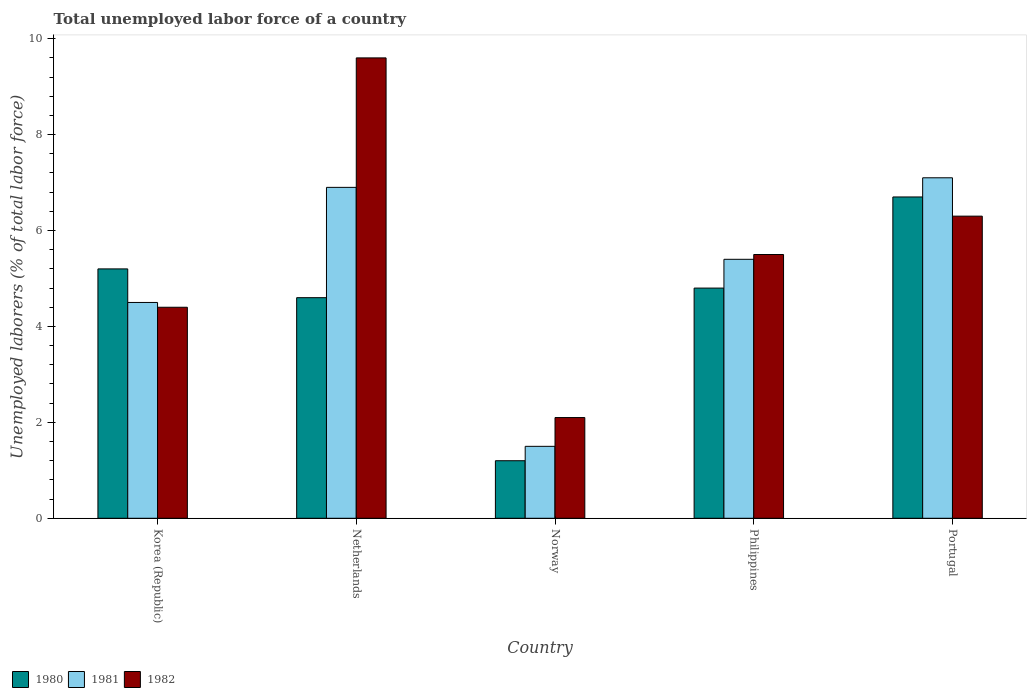How many different coloured bars are there?
Make the answer very short. 3. How many groups of bars are there?
Your answer should be very brief. 5. Are the number of bars per tick equal to the number of legend labels?
Your answer should be compact. Yes. How many bars are there on the 5th tick from the right?
Your answer should be very brief. 3. What is the label of the 3rd group of bars from the left?
Offer a terse response. Norway. What is the total unemployed labor force in 1982 in Netherlands?
Give a very brief answer. 9.6. Across all countries, what is the maximum total unemployed labor force in 1982?
Give a very brief answer. 9.6. Across all countries, what is the minimum total unemployed labor force in 1981?
Ensure brevity in your answer.  1.5. In which country was the total unemployed labor force in 1981 maximum?
Provide a succinct answer. Portugal. In which country was the total unemployed labor force in 1980 minimum?
Make the answer very short. Norway. What is the total total unemployed labor force in 1981 in the graph?
Keep it short and to the point. 25.4. What is the difference between the total unemployed labor force in 1980 in Norway and that in Portugal?
Your response must be concise. -5.5. What is the difference between the total unemployed labor force in 1980 in Norway and the total unemployed labor force in 1982 in Philippines?
Make the answer very short. -4.3. What is the average total unemployed labor force in 1980 per country?
Offer a terse response. 4.5. What is the difference between the total unemployed labor force of/in 1981 and total unemployed labor force of/in 1980 in Norway?
Offer a very short reply. 0.3. What is the ratio of the total unemployed labor force in 1980 in Norway to that in Philippines?
Your response must be concise. 0.25. Is the total unemployed labor force in 1982 in Netherlands less than that in Philippines?
Offer a terse response. No. What is the difference between the highest and the second highest total unemployed labor force in 1980?
Your response must be concise. -0.4. What is the difference between the highest and the lowest total unemployed labor force in 1980?
Keep it short and to the point. 5.5. Is the sum of the total unemployed labor force in 1982 in Netherlands and Philippines greater than the maximum total unemployed labor force in 1981 across all countries?
Provide a succinct answer. Yes. How many bars are there?
Offer a terse response. 15. Are all the bars in the graph horizontal?
Give a very brief answer. No. Are the values on the major ticks of Y-axis written in scientific E-notation?
Keep it short and to the point. No. Does the graph contain any zero values?
Give a very brief answer. No. Does the graph contain grids?
Your response must be concise. No. Where does the legend appear in the graph?
Your response must be concise. Bottom left. What is the title of the graph?
Provide a short and direct response. Total unemployed labor force of a country. What is the label or title of the Y-axis?
Your answer should be compact. Unemployed laborers (% of total labor force). What is the Unemployed laborers (% of total labor force) of 1980 in Korea (Republic)?
Your response must be concise. 5.2. What is the Unemployed laborers (% of total labor force) of 1981 in Korea (Republic)?
Provide a short and direct response. 4.5. What is the Unemployed laborers (% of total labor force) in 1982 in Korea (Republic)?
Offer a terse response. 4.4. What is the Unemployed laborers (% of total labor force) in 1980 in Netherlands?
Offer a very short reply. 4.6. What is the Unemployed laborers (% of total labor force) of 1981 in Netherlands?
Make the answer very short. 6.9. What is the Unemployed laborers (% of total labor force) in 1982 in Netherlands?
Offer a terse response. 9.6. What is the Unemployed laborers (% of total labor force) of 1980 in Norway?
Ensure brevity in your answer.  1.2. What is the Unemployed laborers (% of total labor force) in 1982 in Norway?
Make the answer very short. 2.1. What is the Unemployed laborers (% of total labor force) of 1980 in Philippines?
Offer a terse response. 4.8. What is the Unemployed laborers (% of total labor force) in 1981 in Philippines?
Give a very brief answer. 5.4. What is the Unemployed laborers (% of total labor force) in 1982 in Philippines?
Your response must be concise. 5.5. What is the Unemployed laborers (% of total labor force) in 1980 in Portugal?
Provide a succinct answer. 6.7. What is the Unemployed laborers (% of total labor force) of 1981 in Portugal?
Offer a terse response. 7.1. What is the Unemployed laborers (% of total labor force) of 1982 in Portugal?
Your response must be concise. 6.3. Across all countries, what is the maximum Unemployed laborers (% of total labor force) of 1980?
Your response must be concise. 6.7. Across all countries, what is the maximum Unemployed laborers (% of total labor force) of 1981?
Your answer should be compact. 7.1. Across all countries, what is the maximum Unemployed laborers (% of total labor force) in 1982?
Keep it short and to the point. 9.6. Across all countries, what is the minimum Unemployed laborers (% of total labor force) of 1980?
Provide a short and direct response. 1.2. Across all countries, what is the minimum Unemployed laborers (% of total labor force) of 1982?
Provide a short and direct response. 2.1. What is the total Unemployed laborers (% of total labor force) of 1980 in the graph?
Keep it short and to the point. 22.5. What is the total Unemployed laborers (% of total labor force) of 1981 in the graph?
Offer a terse response. 25.4. What is the total Unemployed laborers (% of total labor force) of 1982 in the graph?
Ensure brevity in your answer.  27.9. What is the difference between the Unemployed laborers (% of total labor force) in 1982 in Korea (Republic) and that in Netherlands?
Provide a succinct answer. -5.2. What is the difference between the Unemployed laborers (% of total labor force) in 1980 in Korea (Republic) and that in Norway?
Offer a very short reply. 4. What is the difference between the Unemployed laborers (% of total labor force) in 1981 in Korea (Republic) and that in Norway?
Your answer should be very brief. 3. What is the difference between the Unemployed laborers (% of total labor force) of 1982 in Korea (Republic) and that in Norway?
Give a very brief answer. 2.3. What is the difference between the Unemployed laborers (% of total labor force) of 1981 in Korea (Republic) and that in Portugal?
Your answer should be very brief. -2.6. What is the difference between the Unemployed laborers (% of total labor force) of 1982 in Korea (Republic) and that in Portugal?
Offer a very short reply. -1.9. What is the difference between the Unemployed laborers (% of total labor force) of 1980 in Netherlands and that in Norway?
Ensure brevity in your answer.  3.4. What is the difference between the Unemployed laborers (% of total labor force) in 1981 in Netherlands and that in Norway?
Provide a succinct answer. 5.4. What is the difference between the Unemployed laborers (% of total labor force) in 1982 in Netherlands and that in Norway?
Offer a terse response. 7.5. What is the difference between the Unemployed laborers (% of total labor force) in 1980 in Netherlands and that in Philippines?
Provide a short and direct response. -0.2. What is the difference between the Unemployed laborers (% of total labor force) of 1980 in Netherlands and that in Portugal?
Offer a terse response. -2.1. What is the difference between the Unemployed laborers (% of total labor force) in 1982 in Netherlands and that in Portugal?
Provide a short and direct response. 3.3. What is the difference between the Unemployed laborers (% of total labor force) of 1980 in Norway and that in Philippines?
Provide a short and direct response. -3.6. What is the difference between the Unemployed laborers (% of total labor force) of 1981 in Norway and that in Philippines?
Make the answer very short. -3.9. What is the difference between the Unemployed laborers (% of total labor force) in 1982 in Norway and that in Philippines?
Your response must be concise. -3.4. What is the difference between the Unemployed laborers (% of total labor force) of 1982 in Norway and that in Portugal?
Your answer should be compact. -4.2. What is the difference between the Unemployed laborers (% of total labor force) in 1980 in Philippines and that in Portugal?
Your answer should be compact. -1.9. What is the difference between the Unemployed laborers (% of total labor force) in 1980 in Korea (Republic) and the Unemployed laborers (% of total labor force) in 1981 in Netherlands?
Your answer should be compact. -1.7. What is the difference between the Unemployed laborers (% of total labor force) of 1980 in Korea (Republic) and the Unemployed laborers (% of total labor force) of 1982 in Norway?
Provide a short and direct response. 3.1. What is the difference between the Unemployed laborers (% of total labor force) in 1980 in Korea (Republic) and the Unemployed laborers (% of total labor force) in 1982 in Philippines?
Your answer should be compact. -0.3. What is the difference between the Unemployed laborers (% of total labor force) of 1981 in Korea (Republic) and the Unemployed laborers (% of total labor force) of 1982 in Philippines?
Your answer should be very brief. -1. What is the difference between the Unemployed laborers (% of total labor force) of 1980 in Korea (Republic) and the Unemployed laborers (% of total labor force) of 1982 in Portugal?
Provide a succinct answer. -1.1. What is the difference between the Unemployed laborers (% of total labor force) of 1981 in Korea (Republic) and the Unemployed laborers (% of total labor force) of 1982 in Portugal?
Your answer should be compact. -1.8. What is the difference between the Unemployed laborers (% of total labor force) of 1980 in Netherlands and the Unemployed laborers (% of total labor force) of 1981 in Norway?
Give a very brief answer. 3.1. What is the difference between the Unemployed laborers (% of total labor force) of 1980 in Netherlands and the Unemployed laborers (% of total labor force) of 1982 in Philippines?
Offer a very short reply. -0.9. What is the difference between the Unemployed laborers (% of total labor force) of 1981 in Netherlands and the Unemployed laborers (% of total labor force) of 1982 in Philippines?
Make the answer very short. 1.4. What is the difference between the Unemployed laborers (% of total labor force) of 1980 in Netherlands and the Unemployed laborers (% of total labor force) of 1981 in Portugal?
Your answer should be very brief. -2.5. What is the difference between the Unemployed laborers (% of total labor force) in 1980 in Netherlands and the Unemployed laborers (% of total labor force) in 1982 in Portugal?
Provide a short and direct response. -1.7. What is the difference between the Unemployed laborers (% of total labor force) in 1980 in Norway and the Unemployed laborers (% of total labor force) in 1982 in Philippines?
Give a very brief answer. -4.3. What is the difference between the Unemployed laborers (% of total labor force) of 1980 in Norway and the Unemployed laborers (% of total labor force) of 1981 in Portugal?
Give a very brief answer. -5.9. What is the difference between the Unemployed laborers (% of total labor force) in 1980 in Norway and the Unemployed laborers (% of total labor force) in 1982 in Portugal?
Provide a succinct answer. -5.1. What is the difference between the Unemployed laborers (% of total labor force) in 1980 in Philippines and the Unemployed laborers (% of total labor force) in 1982 in Portugal?
Your answer should be compact. -1.5. What is the difference between the Unemployed laborers (% of total labor force) in 1981 in Philippines and the Unemployed laborers (% of total labor force) in 1982 in Portugal?
Give a very brief answer. -0.9. What is the average Unemployed laborers (% of total labor force) in 1980 per country?
Offer a very short reply. 4.5. What is the average Unemployed laborers (% of total labor force) of 1981 per country?
Ensure brevity in your answer.  5.08. What is the average Unemployed laborers (% of total labor force) of 1982 per country?
Provide a short and direct response. 5.58. What is the difference between the Unemployed laborers (% of total labor force) in 1980 and Unemployed laborers (% of total labor force) in 1981 in Korea (Republic)?
Make the answer very short. 0.7. What is the difference between the Unemployed laborers (% of total labor force) of 1980 and Unemployed laborers (% of total labor force) of 1982 in Netherlands?
Keep it short and to the point. -5. What is the difference between the Unemployed laborers (% of total labor force) of 1980 and Unemployed laborers (% of total labor force) of 1982 in Norway?
Provide a short and direct response. -0.9. What is the difference between the Unemployed laborers (% of total labor force) in 1981 and Unemployed laborers (% of total labor force) in 1982 in Norway?
Provide a short and direct response. -0.6. What is the difference between the Unemployed laborers (% of total labor force) in 1980 and Unemployed laborers (% of total labor force) in 1982 in Philippines?
Give a very brief answer. -0.7. What is the difference between the Unemployed laborers (% of total labor force) of 1981 and Unemployed laborers (% of total labor force) of 1982 in Philippines?
Your response must be concise. -0.1. What is the difference between the Unemployed laborers (% of total labor force) in 1981 and Unemployed laborers (% of total labor force) in 1982 in Portugal?
Your response must be concise. 0.8. What is the ratio of the Unemployed laborers (% of total labor force) of 1980 in Korea (Republic) to that in Netherlands?
Your answer should be very brief. 1.13. What is the ratio of the Unemployed laborers (% of total labor force) in 1981 in Korea (Republic) to that in Netherlands?
Your answer should be very brief. 0.65. What is the ratio of the Unemployed laborers (% of total labor force) of 1982 in Korea (Republic) to that in Netherlands?
Your response must be concise. 0.46. What is the ratio of the Unemployed laborers (% of total labor force) in 1980 in Korea (Republic) to that in Norway?
Your response must be concise. 4.33. What is the ratio of the Unemployed laborers (% of total labor force) of 1981 in Korea (Republic) to that in Norway?
Your answer should be very brief. 3. What is the ratio of the Unemployed laborers (% of total labor force) in 1982 in Korea (Republic) to that in Norway?
Ensure brevity in your answer.  2.1. What is the ratio of the Unemployed laborers (% of total labor force) of 1980 in Korea (Republic) to that in Philippines?
Your answer should be very brief. 1.08. What is the ratio of the Unemployed laborers (% of total labor force) in 1981 in Korea (Republic) to that in Philippines?
Your response must be concise. 0.83. What is the ratio of the Unemployed laborers (% of total labor force) in 1980 in Korea (Republic) to that in Portugal?
Offer a very short reply. 0.78. What is the ratio of the Unemployed laborers (% of total labor force) in 1981 in Korea (Republic) to that in Portugal?
Provide a short and direct response. 0.63. What is the ratio of the Unemployed laborers (% of total labor force) of 1982 in Korea (Republic) to that in Portugal?
Give a very brief answer. 0.7. What is the ratio of the Unemployed laborers (% of total labor force) of 1980 in Netherlands to that in Norway?
Offer a terse response. 3.83. What is the ratio of the Unemployed laborers (% of total labor force) of 1982 in Netherlands to that in Norway?
Offer a very short reply. 4.57. What is the ratio of the Unemployed laborers (% of total labor force) of 1980 in Netherlands to that in Philippines?
Provide a succinct answer. 0.96. What is the ratio of the Unemployed laborers (% of total labor force) in 1981 in Netherlands to that in Philippines?
Your answer should be compact. 1.28. What is the ratio of the Unemployed laborers (% of total labor force) in 1982 in Netherlands to that in Philippines?
Make the answer very short. 1.75. What is the ratio of the Unemployed laborers (% of total labor force) of 1980 in Netherlands to that in Portugal?
Offer a very short reply. 0.69. What is the ratio of the Unemployed laborers (% of total labor force) in 1981 in Netherlands to that in Portugal?
Your answer should be very brief. 0.97. What is the ratio of the Unemployed laborers (% of total labor force) of 1982 in Netherlands to that in Portugal?
Give a very brief answer. 1.52. What is the ratio of the Unemployed laborers (% of total labor force) in 1980 in Norway to that in Philippines?
Offer a terse response. 0.25. What is the ratio of the Unemployed laborers (% of total labor force) in 1981 in Norway to that in Philippines?
Keep it short and to the point. 0.28. What is the ratio of the Unemployed laborers (% of total labor force) in 1982 in Norway to that in Philippines?
Offer a terse response. 0.38. What is the ratio of the Unemployed laborers (% of total labor force) of 1980 in Norway to that in Portugal?
Keep it short and to the point. 0.18. What is the ratio of the Unemployed laborers (% of total labor force) in 1981 in Norway to that in Portugal?
Offer a very short reply. 0.21. What is the ratio of the Unemployed laborers (% of total labor force) of 1982 in Norway to that in Portugal?
Your answer should be very brief. 0.33. What is the ratio of the Unemployed laborers (% of total labor force) in 1980 in Philippines to that in Portugal?
Provide a short and direct response. 0.72. What is the ratio of the Unemployed laborers (% of total labor force) of 1981 in Philippines to that in Portugal?
Your answer should be very brief. 0.76. What is the ratio of the Unemployed laborers (% of total labor force) in 1982 in Philippines to that in Portugal?
Keep it short and to the point. 0.87. What is the difference between the highest and the second highest Unemployed laborers (% of total labor force) in 1980?
Your answer should be compact. 1.5. What is the difference between the highest and the second highest Unemployed laborers (% of total labor force) in 1981?
Offer a terse response. 0.2. What is the difference between the highest and the second highest Unemployed laborers (% of total labor force) in 1982?
Your response must be concise. 3.3. What is the difference between the highest and the lowest Unemployed laborers (% of total labor force) in 1982?
Provide a succinct answer. 7.5. 